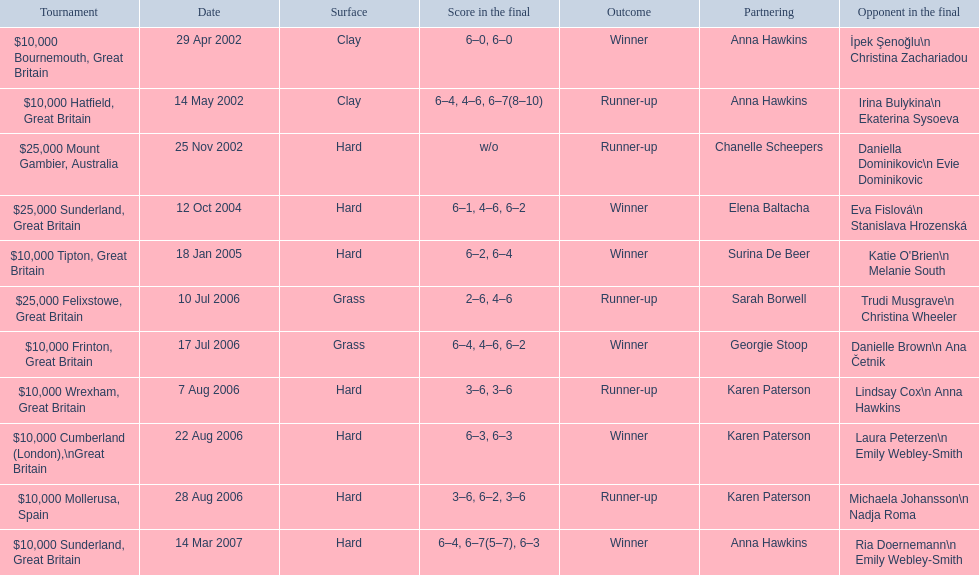How many surfaces are grass? 2. 